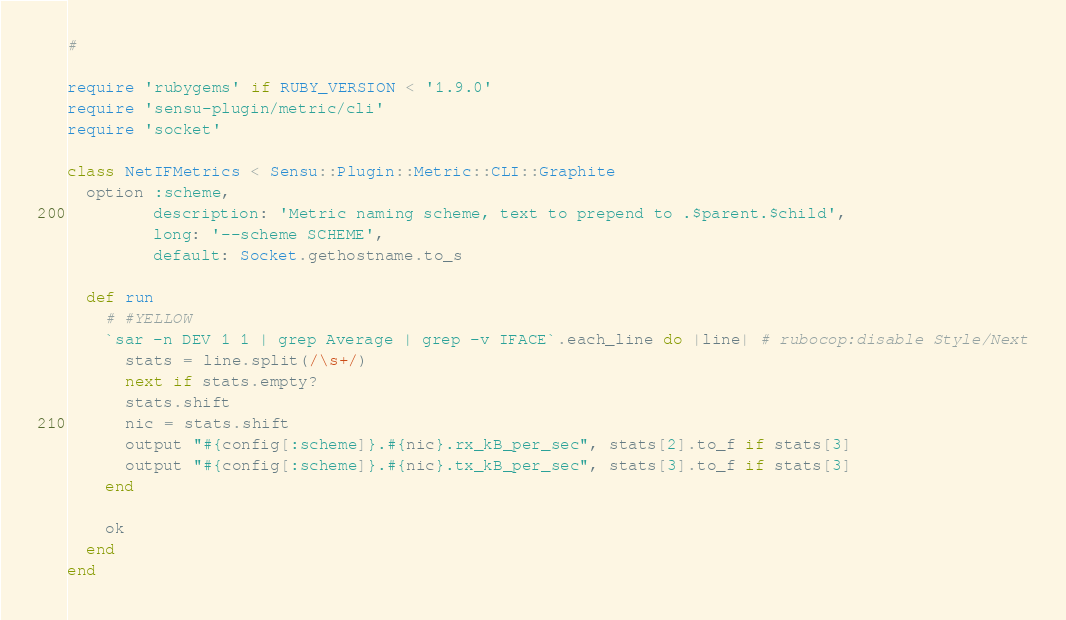Convert code to text. <code><loc_0><loc_0><loc_500><loc_500><_Ruby_>#

require 'rubygems' if RUBY_VERSION < '1.9.0'
require 'sensu-plugin/metric/cli'
require 'socket'

class NetIFMetrics < Sensu::Plugin::Metric::CLI::Graphite
  option :scheme,
         description: 'Metric naming scheme, text to prepend to .$parent.$child',
         long: '--scheme SCHEME',
         default: Socket.gethostname.to_s

  def run
    # #YELLOW
    `sar -n DEV 1 1 | grep Average | grep -v IFACE`.each_line do |line| # rubocop:disable Style/Next
      stats = line.split(/\s+/)
      next if stats.empty?
      stats.shift
      nic = stats.shift
      output "#{config[:scheme]}.#{nic}.rx_kB_per_sec", stats[2].to_f if stats[3]
      output "#{config[:scheme]}.#{nic}.tx_kB_per_sec", stats[3].to_f if stats[3]
    end

    ok
  end
end
</code> 